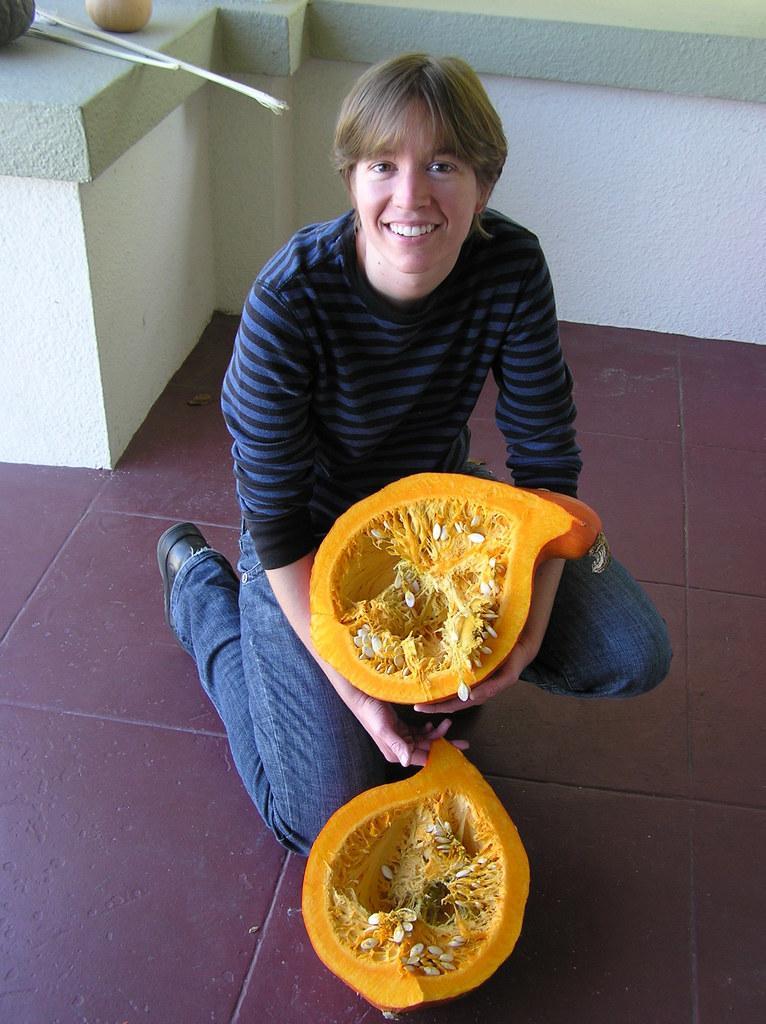Please provide a concise description of this image. In this image we can see there is a person sitting on the floor and holding a pumpkin. At the back there is a wall and on the wall there are sticks and vegetables on it. 